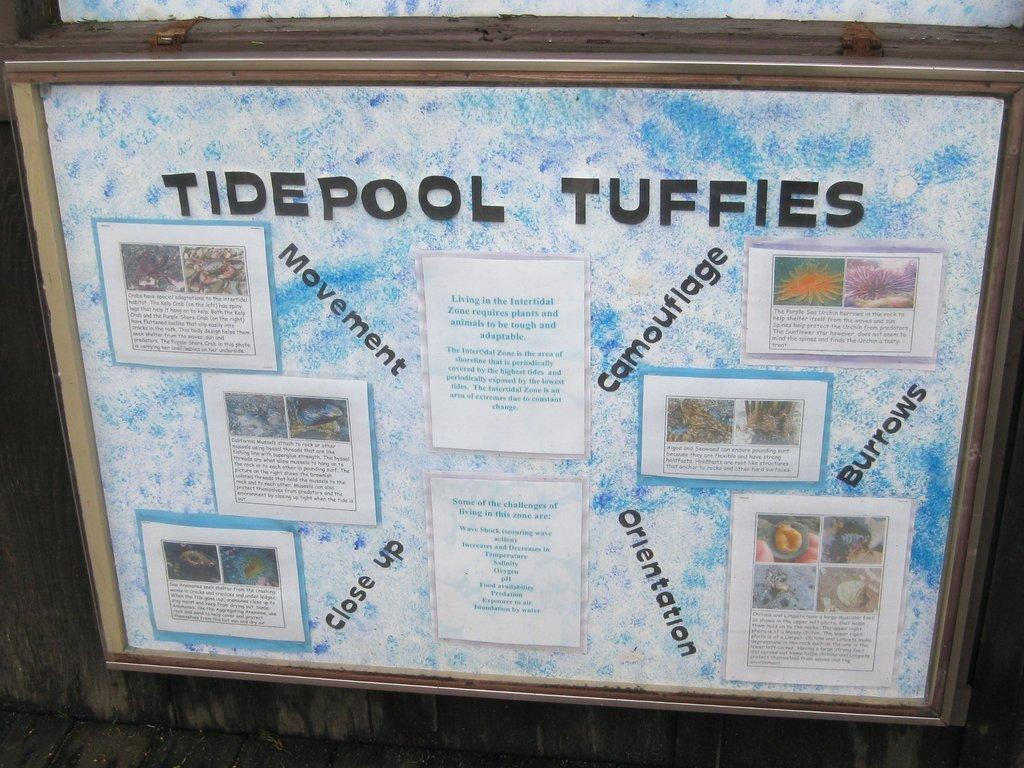<image>
Share a concise interpretation of the image provided. A bulleton board with the head line TIDEPOOL TUFFIES. 